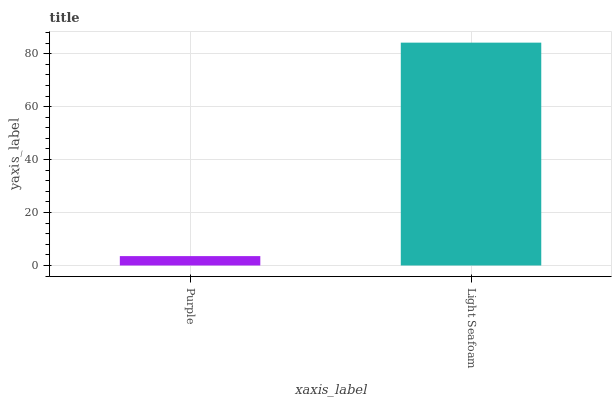Is Purple the minimum?
Answer yes or no. Yes. Is Light Seafoam the maximum?
Answer yes or no. Yes. Is Light Seafoam the minimum?
Answer yes or no. No. Is Light Seafoam greater than Purple?
Answer yes or no. Yes. Is Purple less than Light Seafoam?
Answer yes or no. Yes. Is Purple greater than Light Seafoam?
Answer yes or no. No. Is Light Seafoam less than Purple?
Answer yes or no. No. Is Light Seafoam the high median?
Answer yes or no. Yes. Is Purple the low median?
Answer yes or no. Yes. Is Purple the high median?
Answer yes or no. No. Is Light Seafoam the low median?
Answer yes or no. No. 